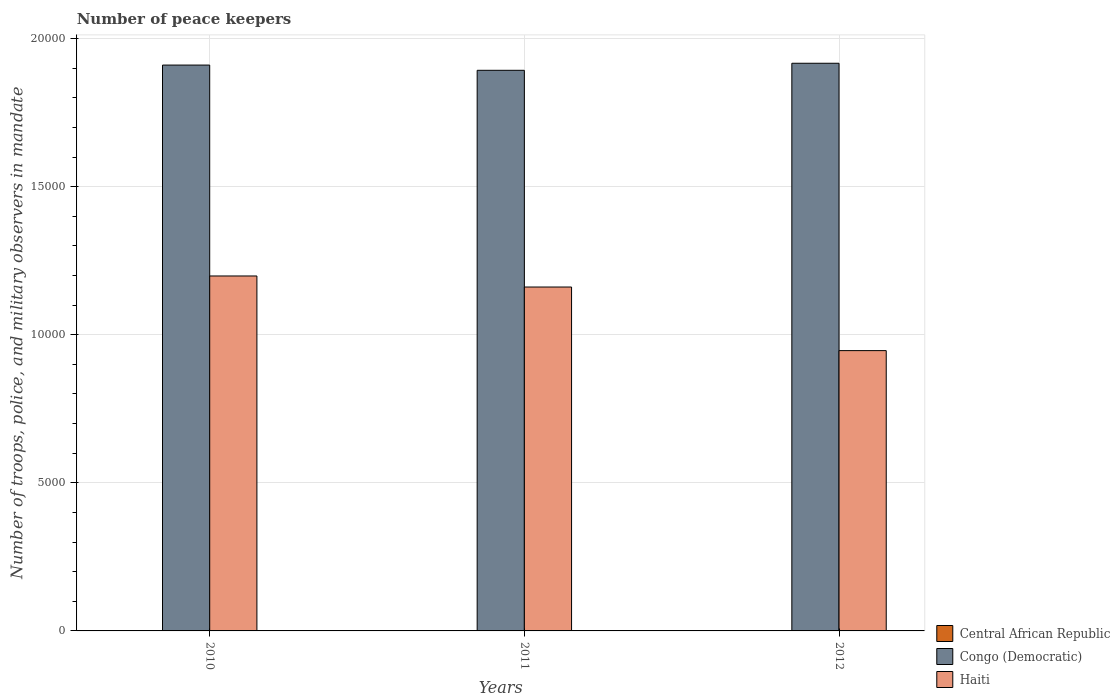How many different coloured bars are there?
Ensure brevity in your answer.  3. Are the number of bars per tick equal to the number of legend labels?
Provide a short and direct response. Yes. How many bars are there on the 3rd tick from the left?
Ensure brevity in your answer.  3. How many bars are there on the 2nd tick from the right?
Your answer should be very brief. 3. In how many cases, is the number of bars for a given year not equal to the number of legend labels?
Make the answer very short. 0. What is the number of peace keepers in in Haiti in 2011?
Offer a very short reply. 1.16e+04. Across all years, what is the maximum number of peace keepers in in Congo (Democratic)?
Provide a short and direct response. 1.92e+04. In which year was the number of peace keepers in in Central African Republic maximum?
Keep it short and to the point. 2011. In which year was the number of peace keepers in in Haiti minimum?
Provide a short and direct response. 2012. What is the total number of peace keepers in in Congo (Democratic) in the graph?
Your response must be concise. 5.72e+04. What is the difference between the number of peace keepers in in Central African Republic in 2010 and the number of peace keepers in in Congo (Democratic) in 2012?
Ensure brevity in your answer.  -1.92e+04. What is the average number of peace keepers in in Haiti per year?
Keep it short and to the point. 1.10e+04. In the year 2010, what is the difference between the number of peace keepers in in Central African Republic and number of peace keepers in in Haiti?
Provide a short and direct response. -1.20e+04. In how many years, is the number of peace keepers in in Haiti greater than 3000?
Make the answer very short. 3. What is the ratio of the number of peace keepers in in Haiti in 2011 to that in 2012?
Ensure brevity in your answer.  1.23. Is the difference between the number of peace keepers in in Central African Republic in 2011 and 2012 greater than the difference between the number of peace keepers in in Haiti in 2011 and 2012?
Offer a terse response. No. What is the difference between the highest and the lowest number of peace keepers in in Haiti?
Your answer should be very brief. 2520. In how many years, is the number of peace keepers in in Congo (Democratic) greater than the average number of peace keepers in in Congo (Democratic) taken over all years?
Ensure brevity in your answer.  2. Is the sum of the number of peace keepers in in Haiti in 2011 and 2012 greater than the maximum number of peace keepers in in Congo (Democratic) across all years?
Your answer should be compact. Yes. What does the 1st bar from the left in 2010 represents?
Provide a succinct answer. Central African Republic. What does the 3rd bar from the right in 2012 represents?
Offer a very short reply. Central African Republic. Are all the bars in the graph horizontal?
Give a very brief answer. No. How many years are there in the graph?
Make the answer very short. 3. Are the values on the major ticks of Y-axis written in scientific E-notation?
Provide a short and direct response. No. How are the legend labels stacked?
Provide a short and direct response. Vertical. What is the title of the graph?
Ensure brevity in your answer.  Number of peace keepers. What is the label or title of the Y-axis?
Make the answer very short. Number of troops, police, and military observers in mandate. What is the Number of troops, police, and military observers in mandate in Central African Republic in 2010?
Keep it short and to the point. 3. What is the Number of troops, police, and military observers in mandate in Congo (Democratic) in 2010?
Offer a terse response. 1.91e+04. What is the Number of troops, police, and military observers in mandate of Haiti in 2010?
Ensure brevity in your answer.  1.20e+04. What is the Number of troops, police, and military observers in mandate of Central African Republic in 2011?
Give a very brief answer. 4. What is the Number of troops, police, and military observers in mandate in Congo (Democratic) in 2011?
Ensure brevity in your answer.  1.89e+04. What is the Number of troops, police, and military observers in mandate in Haiti in 2011?
Keep it short and to the point. 1.16e+04. What is the Number of troops, police, and military observers in mandate in Congo (Democratic) in 2012?
Offer a very short reply. 1.92e+04. What is the Number of troops, police, and military observers in mandate of Haiti in 2012?
Provide a succinct answer. 9464. Across all years, what is the maximum Number of troops, police, and military observers in mandate in Central African Republic?
Offer a very short reply. 4. Across all years, what is the maximum Number of troops, police, and military observers in mandate of Congo (Democratic)?
Your answer should be compact. 1.92e+04. Across all years, what is the maximum Number of troops, police, and military observers in mandate of Haiti?
Make the answer very short. 1.20e+04. Across all years, what is the minimum Number of troops, police, and military observers in mandate in Central African Republic?
Your response must be concise. 3. Across all years, what is the minimum Number of troops, police, and military observers in mandate of Congo (Democratic)?
Provide a short and direct response. 1.89e+04. Across all years, what is the minimum Number of troops, police, and military observers in mandate in Haiti?
Your answer should be very brief. 9464. What is the total Number of troops, police, and military observers in mandate of Congo (Democratic) in the graph?
Keep it short and to the point. 5.72e+04. What is the total Number of troops, police, and military observers in mandate in Haiti in the graph?
Your response must be concise. 3.31e+04. What is the difference between the Number of troops, police, and military observers in mandate in Central African Republic in 2010 and that in 2011?
Give a very brief answer. -1. What is the difference between the Number of troops, police, and military observers in mandate of Congo (Democratic) in 2010 and that in 2011?
Your response must be concise. 177. What is the difference between the Number of troops, police, and military observers in mandate of Haiti in 2010 and that in 2011?
Provide a succinct answer. 373. What is the difference between the Number of troops, police, and military observers in mandate in Central African Republic in 2010 and that in 2012?
Keep it short and to the point. -1. What is the difference between the Number of troops, police, and military observers in mandate of Congo (Democratic) in 2010 and that in 2012?
Give a very brief answer. -61. What is the difference between the Number of troops, police, and military observers in mandate in Haiti in 2010 and that in 2012?
Provide a succinct answer. 2520. What is the difference between the Number of troops, police, and military observers in mandate in Congo (Democratic) in 2011 and that in 2012?
Keep it short and to the point. -238. What is the difference between the Number of troops, police, and military observers in mandate in Haiti in 2011 and that in 2012?
Make the answer very short. 2147. What is the difference between the Number of troops, police, and military observers in mandate in Central African Republic in 2010 and the Number of troops, police, and military observers in mandate in Congo (Democratic) in 2011?
Keep it short and to the point. -1.89e+04. What is the difference between the Number of troops, police, and military observers in mandate of Central African Republic in 2010 and the Number of troops, police, and military observers in mandate of Haiti in 2011?
Your answer should be very brief. -1.16e+04. What is the difference between the Number of troops, police, and military observers in mandate in Congo (Democratic) in 2010 and the Number of troops, police, and military observers in mandate in Haiti in 2011?
Ensure brevity in your answer.  7494. What is the difference between the Number of troops, police, and military observers in mandate in Central African Republic in 2010 and the Number of troops, police, and military observers in mandate in Congo (Democratic) in 2012?
Make the answer very short. -1.92e+04. What is the difference between the Number of troops, police, and military observers in mandate in Central African Republic in 2010 and the Number of troops, police, and military observers in mandate in Haiti in 2012?
Offer a terse response. -9461. What is the difference between the Number of troops, police, and military observers in mandate of Congo (Democratic) in 2010 and the Number of troops, police, and military observers in mandate of Haiti in 2012?
Your answer should be compact. 9641. What is the difference between the Number of troops, police, and military observers in mandate in Central African Republic in 2011 and the Number of troops, police, and military observers in mandate in Congo (Democratic) in 2012?
Keep it short and to the point. -1.92e+04. What is the difference between the Number of troops, police, and military observers in mandate in Central African Republic in 2011 and the Number of troops, police, and military observers in mandate in Haiti in 2012?
Offer a very short reply. -9460. What is the difference between the Number of troops, police, and military observers in mandate in Congo (Democratic) in 2011 and the Number of troops, police, and military observers in mandate in Haiti in 2012?
Offer a terse response. 9464. What is the average Number of troops, police, and military observers in mandate in Central African Republic per year?
Provide a succinct answer. 3.67. What is the average Number of troops, police, and military observers in mandate of Congo (Democratic) per year?
Your answer should be compact. 1.91e+04. What is the average Number of troops, police, and military observers in mandate in Haiti per year?
Ensure brevity in your answer.  1.10e+04. In the year 2010, what is the difference between the Number of troops, police, and military observers in mandate of Central African Republic and Number of troops, police, and military observers in mandate of Congo (Democratic)?
Offer a very short reply. -1.91e+04. In the year 2010, what is the difference between the Number of troops, police, and military observers in mandate in Central African Republic and Number of troops, police, and military observers in mandate in Haiti?
Ensure brevity in your answer.  -1.20e+04. In the year 2010, what is the difference between the Number of troops, police, and military observers in mandate in Congo (Democratic) and Number of troops, police, and military observers in mandate in Haiti?
Provide a succinct answer. 7121. In the year 2011, what is the difference between the Number of troops, police, and military observers in mandate in Central African Republic and Number of troops, police, and military observers in mandate in Congo (Democratic)?
Your response must be concise. -1.89e+04. In the year 2011, what is the difference between the Number of troops, police, and military observers in mandate of Central African Republic and Number of troops, police, and military observers in mandate of Haiti?
Provide a succinct answer. -1.16e+04. In the year 2011, what is the difference between the Number of troops, police, and military observers in mandate in Congo (Democratic) and Number of troops, police, and military observers in mandate in Haiti?
Provide a short and direct response. 7317. In the year 2012, what is the difference between the Number of troops, police, and military observers in mandate in Central African Republic and Number of troops, police, and military observers in mandate in Congo (Democratic)?
Your answer should be compact. -1.92e+04. In the year 2012, what is the difference between the Number of troops, police, and military observers in mandate in Central African Republic and Number of troops, police, and military observers in mandate in Haiti?
Your answer should be compact. -9460. In the year 2012, what is the difference between the Number of troops, police, and military observers in mandate of Congo (Democratic) and Number of troops, police, and military observers in mandate of Haiti?
Ensure brevity in your answer.  9702. What is the ratio of the Number of troops, police, and military observers in mandate in Central African Republic in 2010 to that in 2011?
Provide a succinct answer. 0.75. What is the ratio of the Number of troops, police, and military observers in mandate of Congo (Democratic) in 2010 to that in 2011?
Offer a terse response. 1.01. What is the ratio of the Number of troops, police, and military observers in mandate of Haiti in 2010 to that in 2011?
Ensure brevity in your answer.  1.03. What is the ratio of the Number of troops, police, and military observers in mandate in Central African Republic in 2010 to that in 2012?
Your response must be concise. 0.75. What is the ratio of the Number of troops, police, and military observers in mandate in Congo (Democratic) in 2010 to that in 2012?
Ensure brevity in your answer.  1. What is the ratio of the Number of troops, police, and military observers in mandate of Haiti in 2010 to that in 2012?
Ensure brevity in your answer.  1.27. What is the ratio of the Number of troops, police, and military observers in mandate of Central African Republic in 2011 to that in 2012?
Give a very brief answer. 1. What is the ratio of the Number of troops, police, and military observers in mandate of Congo (Democratic) in 2011 to that in 2012?
Provide a short and direct response. 0.99. What is the ratio of the Number of troops, police, and military observers in mandate in Haiti in 2011 to that in 2012?
Your response must be concise. 1.23. What is the difference between the highest and the second highest Number of troops, police, and military observers in mandate in Haiti?
Offer a terse response. 373. What is the difference between the highest and the lowest Number of troops, police, and military observers in mandate of Congo (Democratic)?
Your response must be concise. 238. What is the difference between the highest and the lowest Number of troops, police, and military observers in mandate of Haiti?
Provide a short and direct response. 2520. 